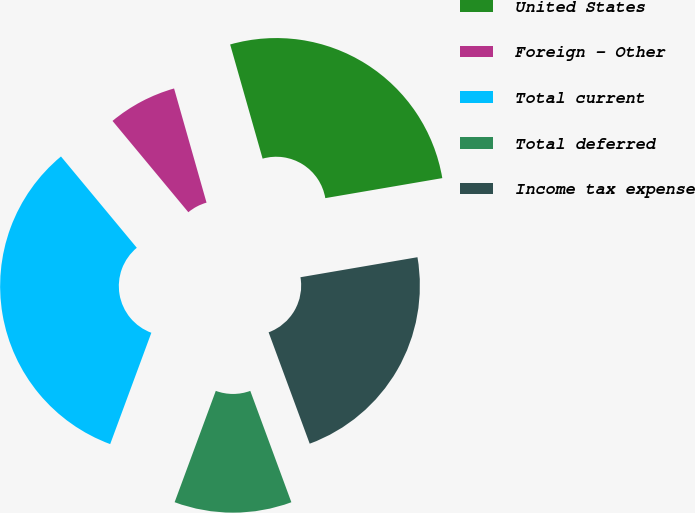Convert chart. <chart><loc_0><loc_0><loc_500><loc_500><pie_chart><fcel>United States<fcel>Foreign - Other<fcel>Total current<fcel>Total deferred<fcel>Income tax expense<nl><fcel>26.71%<fcel>6.62%<fcel>33.33%<fcel>11.26%<fcel>22.07%<nl></chart> 